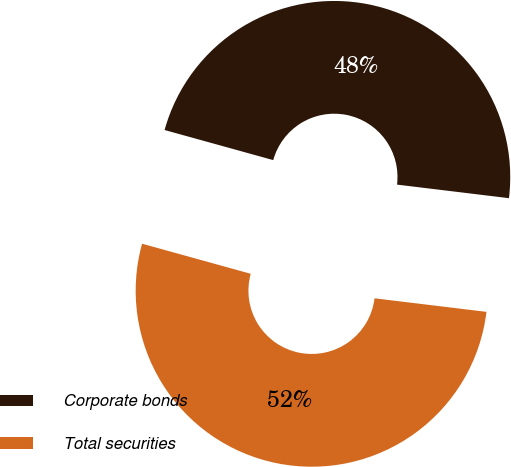<chart> <loc_0><loc_0><loc_500><loc_500><pie_chart><fcel>Corporate bonds<fcel>Total securities<nl><fcel>47.62%<fcel>52.38%<nl></chart> 